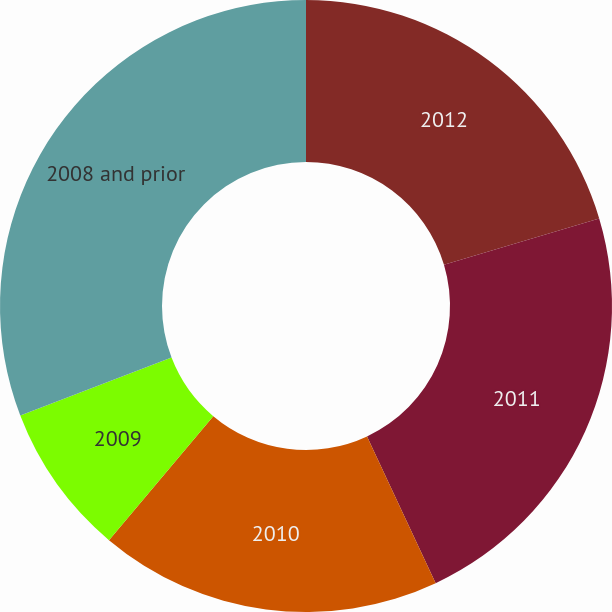Convert chart to OTSL. <chart><loc_0><loc_0><loc_500><loc_500><pie_chart><fcel>2012<fcel>2011<fcel>2010<fcel>2009<fcel>2008 and prior<nl><fcel>20.38%<fcel>22.66%<fcel>18.1%<fcel>8.04%<fcel>30.83%<nl></chart> 